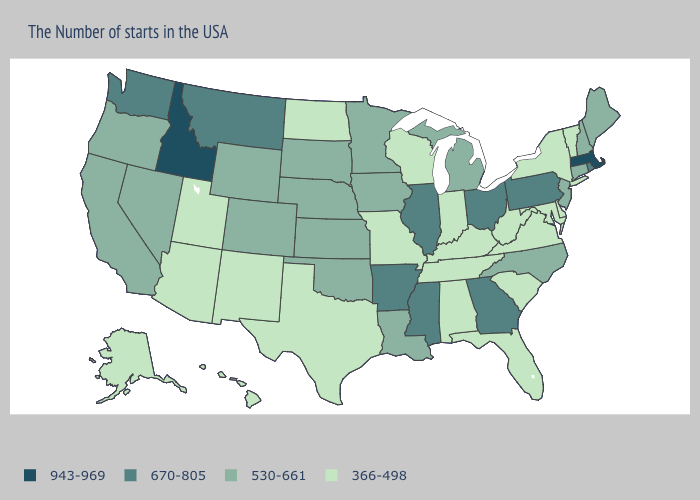Which states have the lowest value in the South?
Short answer required. Delaware, Maryland, Virginia, South Carolina, West Virginia, Florida, Kentucky, Alabama, Tennessee, Texas. Does Missouri have the lowest value in the MidWest?
Write a very short answer. Yes. What is the value of Colorado?
Answer briefly. 530-661. Among the states that border Wyoming , does Utah have the lowest value?
Be succinct. Yes. Does Pennsylvania have the lowest value in the USA?
Give a very brief answer. No. What is the lowest value in the MidWest?
Give a very brief answer. 366-498. What is the value of Colorado?
Keep it brief. 530-661. What is the value of Wisconsin?
Keep it brief. 366-498. What is the highest value in the South ?
Quick response, please. 670-805. What is the value of New York?
Short answer required. 366-498. What is the lowest value in the USA?
Give a very brief answer. 366-498. What is the value of Indiana?
Answer briefly. 366-498. Does Minnesota have the same value as Virginia?
Short answer required. No. How many symbols are there in the legend?
Short answer required. 4. What is the value of Minnesota?
Quick response, please. 530-661. 